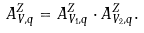<formula> <loc_0><loc_0><loc_500><loc_500>A ^ { Z } _ { V , q } = A ^ { Z } _ { V _ { 1 } , q } \cdot A ^ { Z } _ { V _ { 2 } , q } .</formula> 